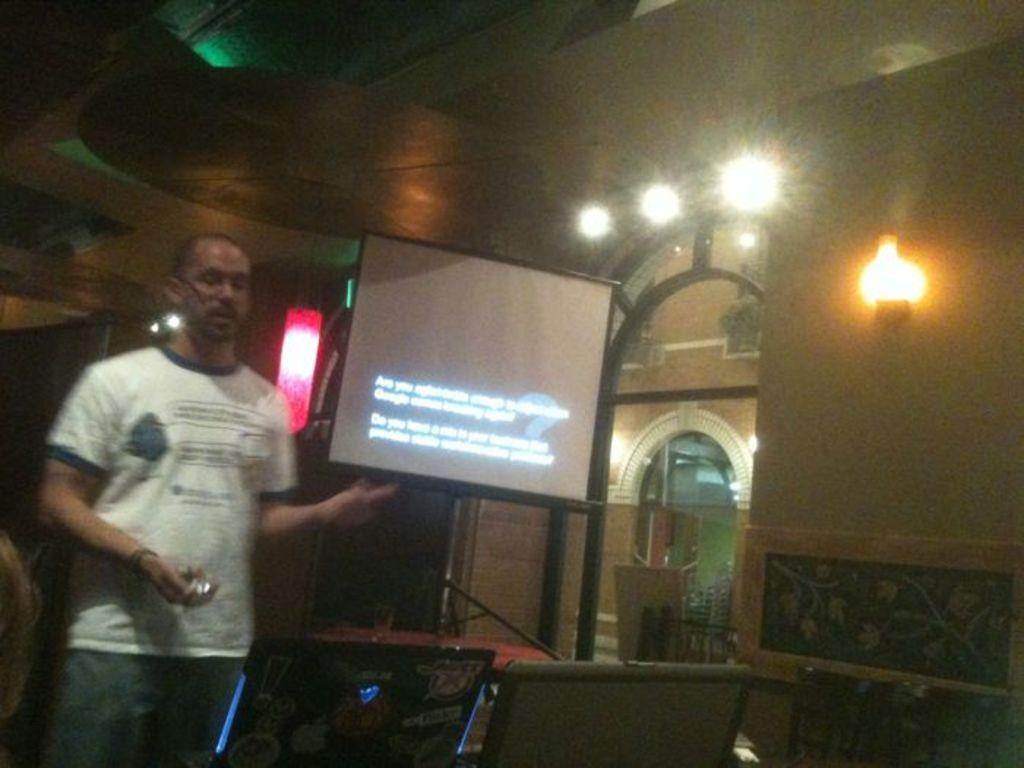What is the main subject in the image? There is a man standing in the image. Where is the man standing? The man is standing on the floor. What objects can be seen on a table in the image? There are laptops on a table in the image. What type of sign is present in the image? There is an information board in the image. What type of lighting is visible in the image? Electric lights are visible in the image. What architectural features are present in the image? There are doors and walls in the image. What type of frame is the man wearing in the image? There is no frame present in the image; the man is not wearing any type of frame. 